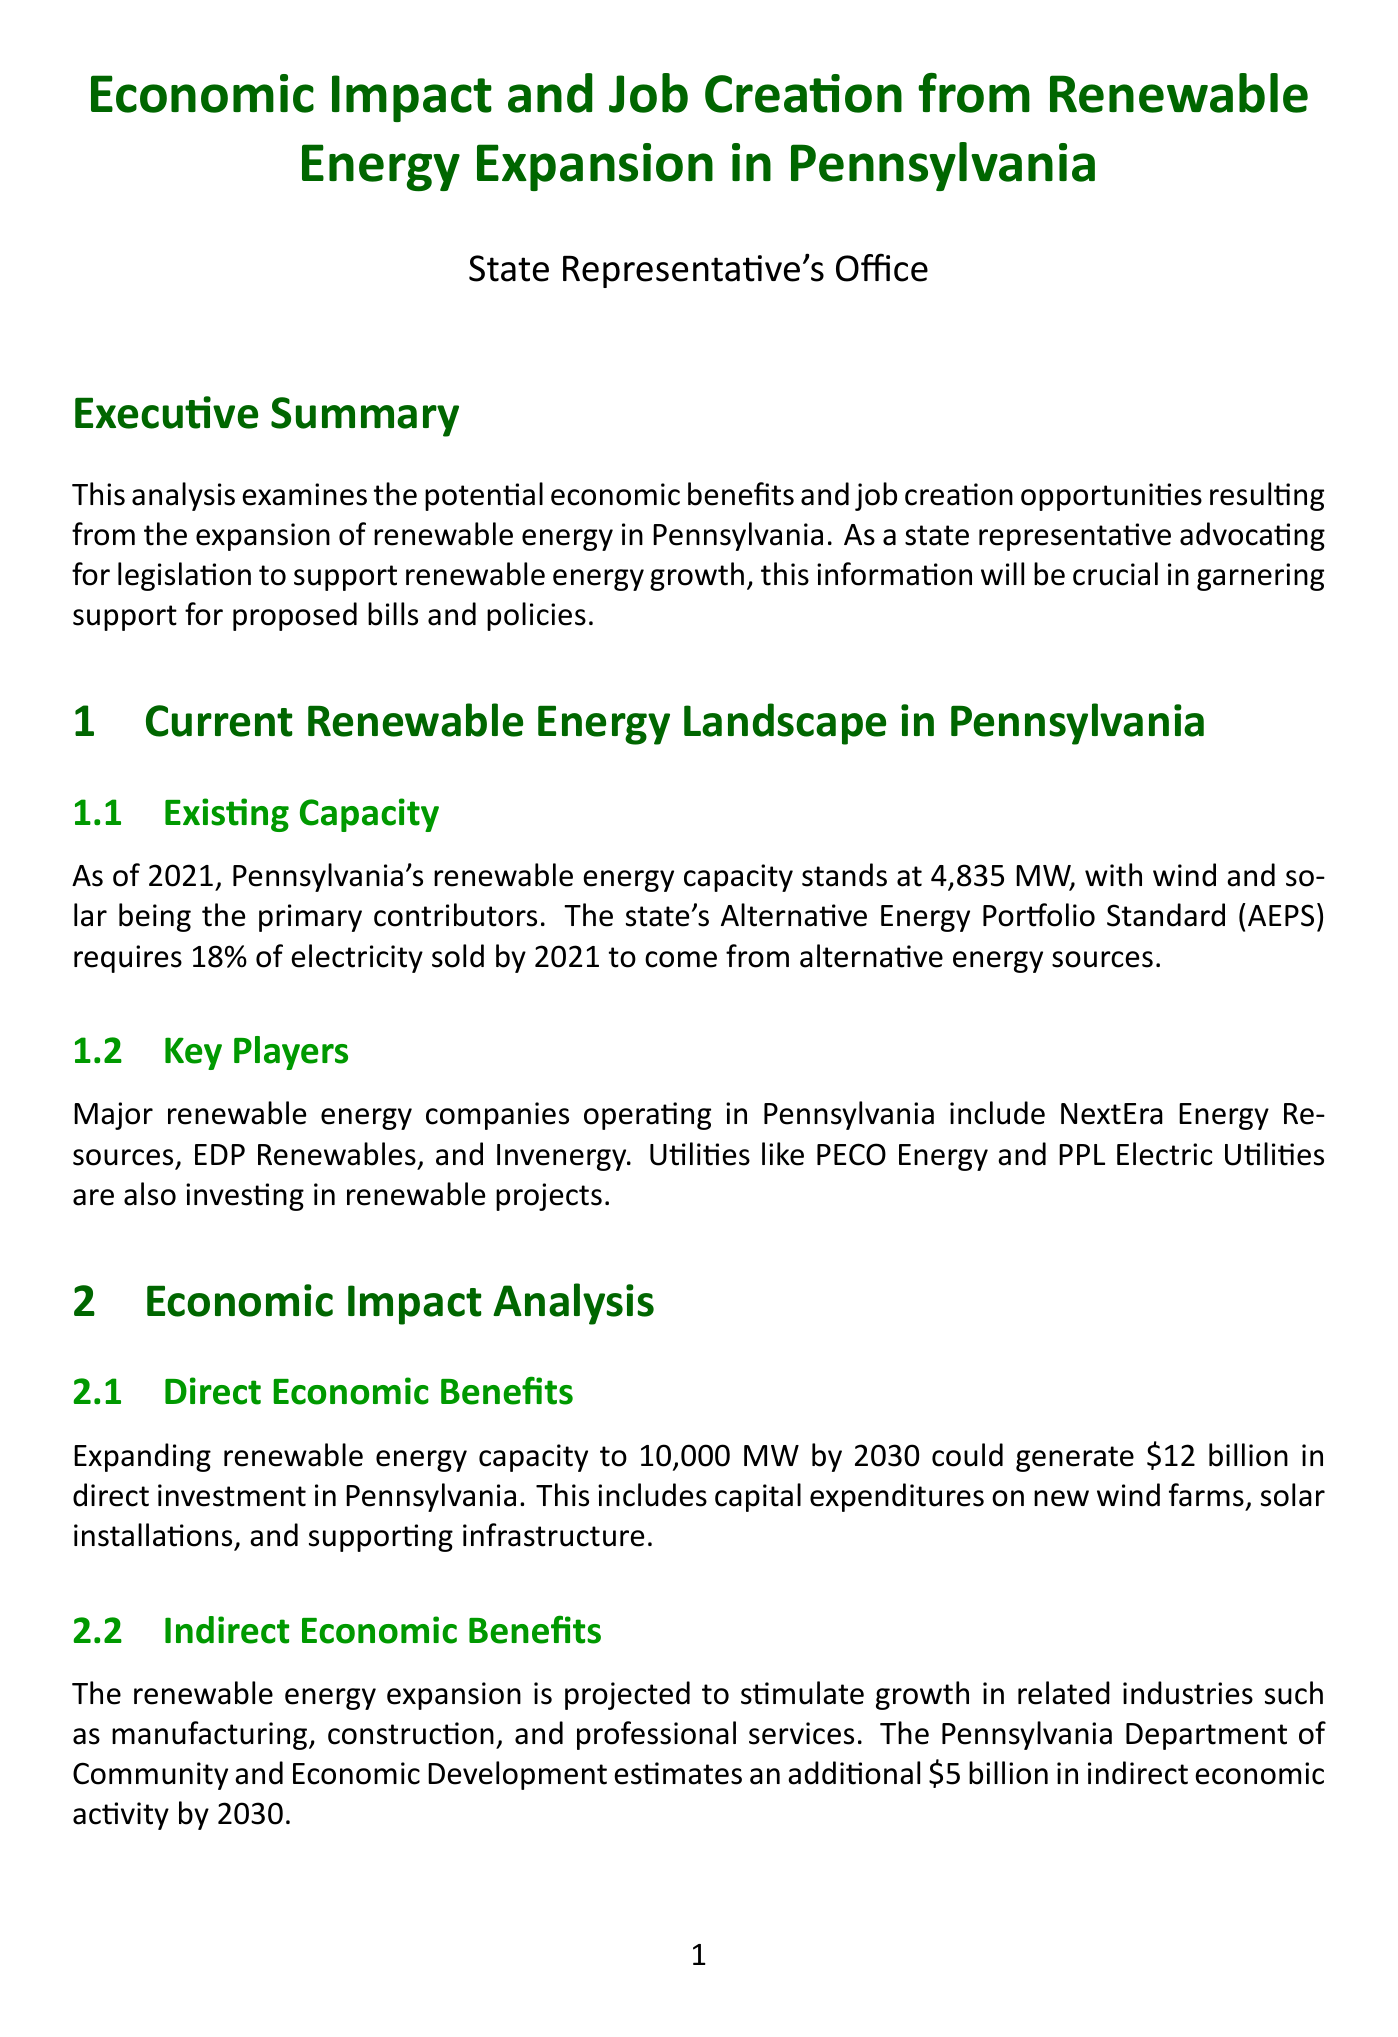What is the renewable energy capacity in Pennsylvania as of 2021? The document states that Pennsylvania's renewable energy capacity stands at 4,835 MW as of 2021.
Answer: 4,835 MW How many direct jobs are expected to be created by 2030 from renewable energy expansion? The document indicates that the expansion of renewable energy capacity is expected to create 50,000 direct jobs by 2030.
Answer: 50,000 What is the projected reduction in electricity costs for consumers by 2035? According to the University of Pennsylvania's study, increased renewable energy generation could lead to a 10-15% reduction in electricity costs for consumers by 2035.
Answer: 10-15% What is the estimated total direct investment in Pennsylvania from renewable energy expansion? The analysis mentions that expanding renewable energy capacity to 10,000 MW by 2030 could generate $12 billion in direct investment in Pennsylvania.
Answer: $12 billion Which two cities are highlighted as potential hubs for renewable energy companies? The document identifies Philadelphia and Pittsburgh as cities poised to become hubs for renewable energy companies.
Answer: Philadelphia and Pittsburgh What additional economic activity is projected from the expansion of renewable energy by 2030? The document states that the renewable energy expansion is projected to stimulate an additional $5 billion in indirect economic activity by 2030.
Answer: $5 billion What policy recommendation could drive an additional $8 billion in economic activity? The document suggests proposing legislation to increase the state's renewable energy target to 35% by 2035 as a policy recommendation that could drive additional economic activity.
Answer: Increase the state's renewable energy target to 35% by 2035 What funding amount is proposed for renewable energy workforce development programs? The document proposes establishing a $50 million annual fund for renewable energy workforce development programs.
Answer: $50 million How many indirect and induced jobs are projected to be created alongside direct jobs? According to the document, an additional 75,000 indirect and induced jobs are projected to be created.
Answer: 75,000 